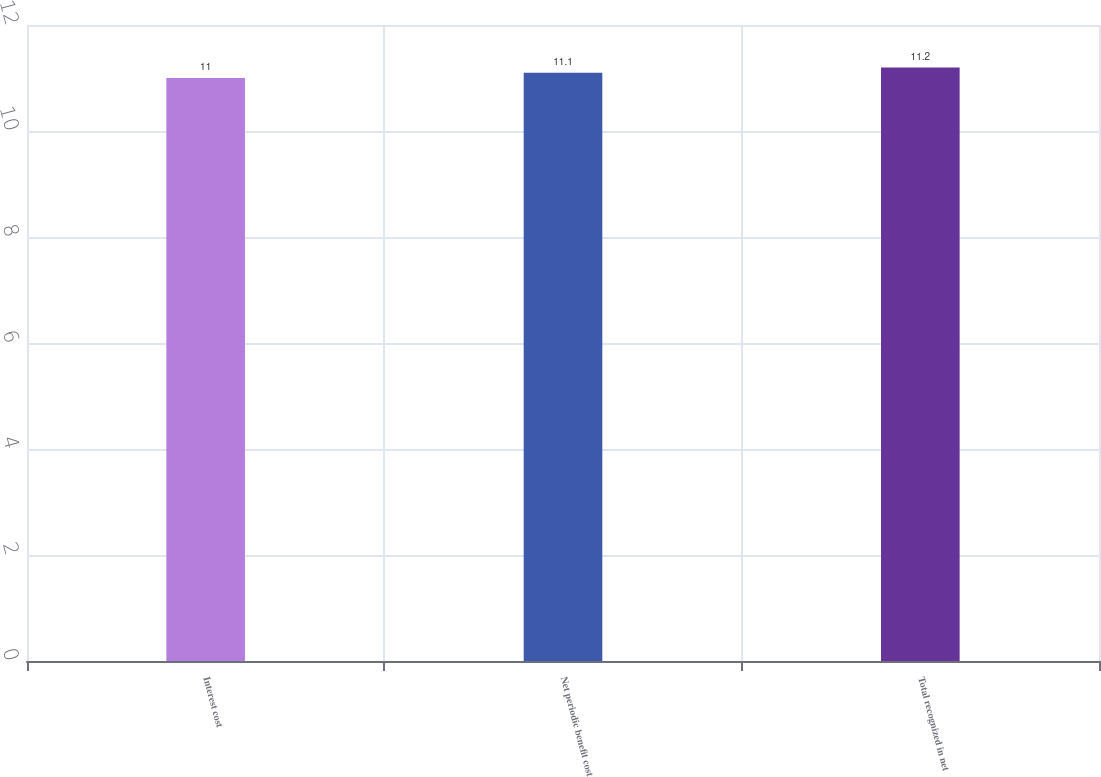Convert chart to OTSL. <chart><loc_0><loc_0><loc_500><loc_500><bar_chart><fcel>Interest cost<fcel>Net periodic benefit cost<fcel>Total recognized in net<nl><fcel>11<fcel>11.1<fcel>11.2<nl></chart> 